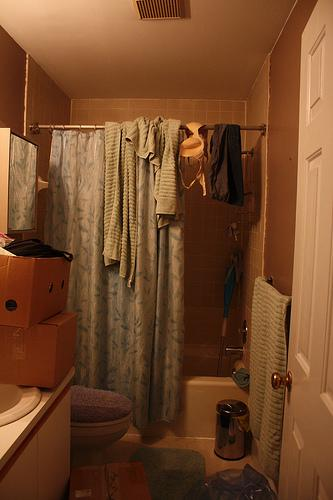Question: what is pictured?
Choices:
A. Clouds.
B. A bathroom.
C. Dogs.
D. Cats.
Answer with the letter. Answer: B Question: where is the bra?
Choices:
A. On the shower curtain.
B. On the hanger.
C. In the closet.
D. On the floor.
Answer with the letter. Answer: A Question: where is the medicine cabinet?
Choices:
A. In the bathroom.
B. On the right.
C. On the left.
D. Above the sink.
Answer with the letter. Answer: C Question: what are the boxes made of?
Choices:
A. Wood.
B. Cardboard.
C. Steel.
D. Copper.
Answer with the letter. Answer: B 